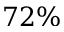<formula> <loc_0><loc_0><loc_500><loc_500>7 2 \%</formula> 